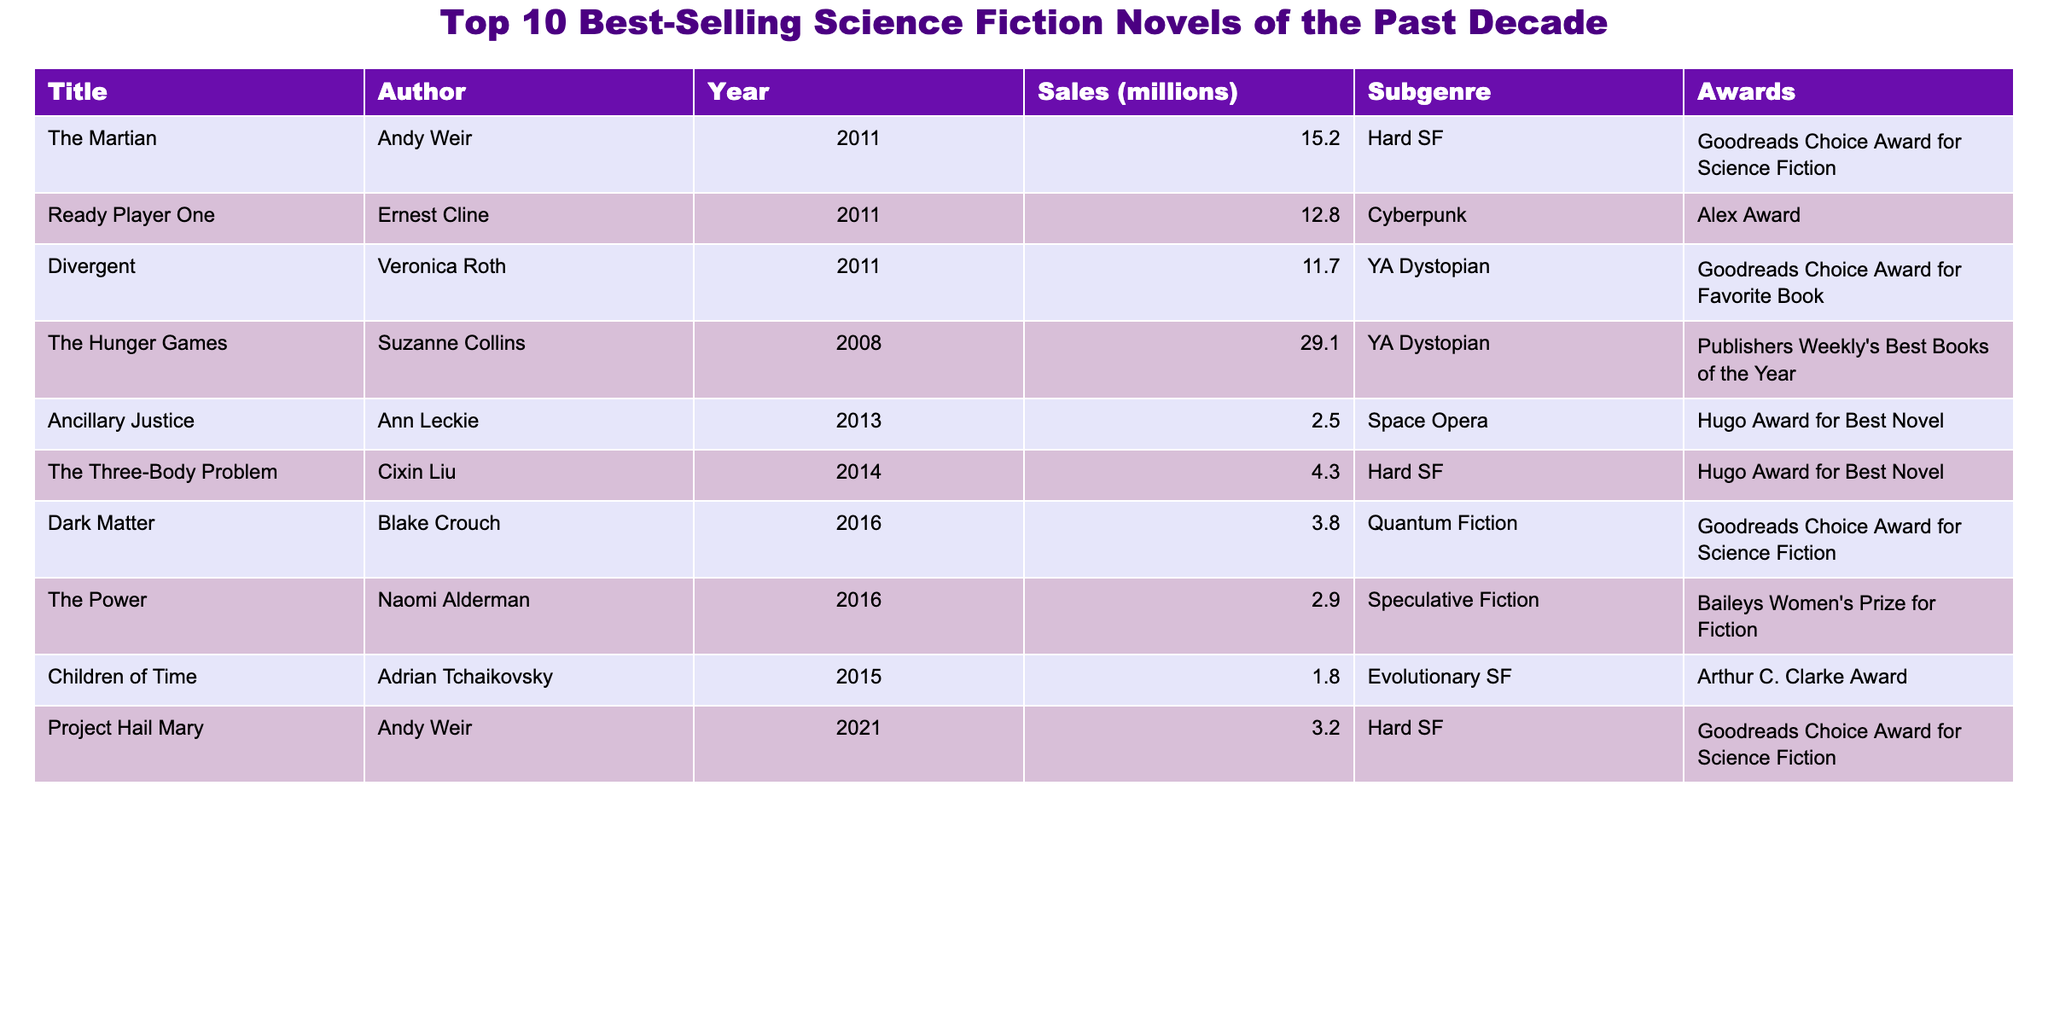What is the title of the best-selling science fiction novel? The best-selling science fiction novel is "The Hunger Games" with sales of 29.1 million copies.
Answer: "The Hunger Games" How many books have sales of over 10 million? The novels "The Hunger Games," "The Martian," "Ready Player One," and "Divergent" have sales over 10 million copies, which totals to 4 books.
Answer: 4 Which author has the highest sales for a single book? "The Hunger Games" by Suzanne Collins has the highest sales of 29.1 million copies among all the listed novels.
Answer: Suzanne Collins Is "Ancillary Justice" among the top three best-selling books? "Ancillary Justice" has sales of only 2.5 million, which does not place it among the top three.
Answer: No What is the average sales of all the listed novels? Total sales are 88.9 million from 10 novels, so the average is 88.9 million / 10 = 8.89 million.
Answer: 8.89 million Which novel won the Hugo Award for Best Novel? "Ancillary Justice" and "The Three-Body Problem" both won the Hugo Award for Best Novel.
Answer: "Ancillary Justice" and "The Three-Body Problem" Is there a book in the table that has won more than one major award? Each book listed only won one major award, based on the table.
Answer: No What is the total sales of the books in the "YA Dystopian" subgenre? "Divergent" (11.7 million) + "The Hunger Games" (29.1 million) = 40.8 million in total sales for the YA Dystopian subgenre.
Answer: 40.8 million How many novels were written by Andy Weir? Andy Weir wrote two novels in the list, "The Martian" and "Project Hail Mary."
Answer: 2 Who won the Goodreads Choice Award for Science Fiction the most times among these novels? Both "The Martian" and "Dark Matter" won the Goodreads Choice Award for Science Fiction, each one time.
Answer: "The Martian" and "Dark Matter" 